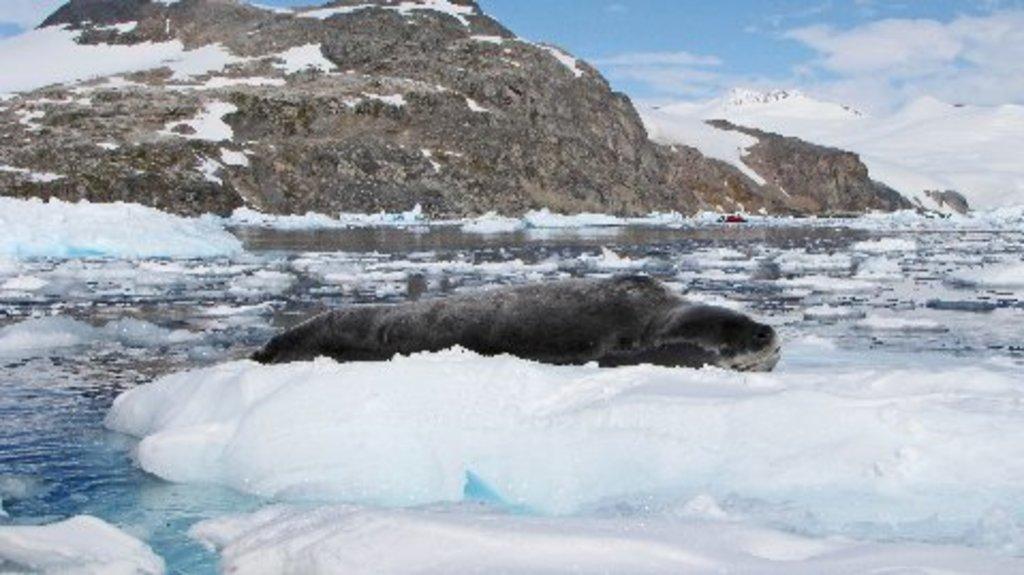Can you describe this image briefly? At the bottom of the image we can see some ice and water. At the top of the image there are some hills and clouds and sky. 